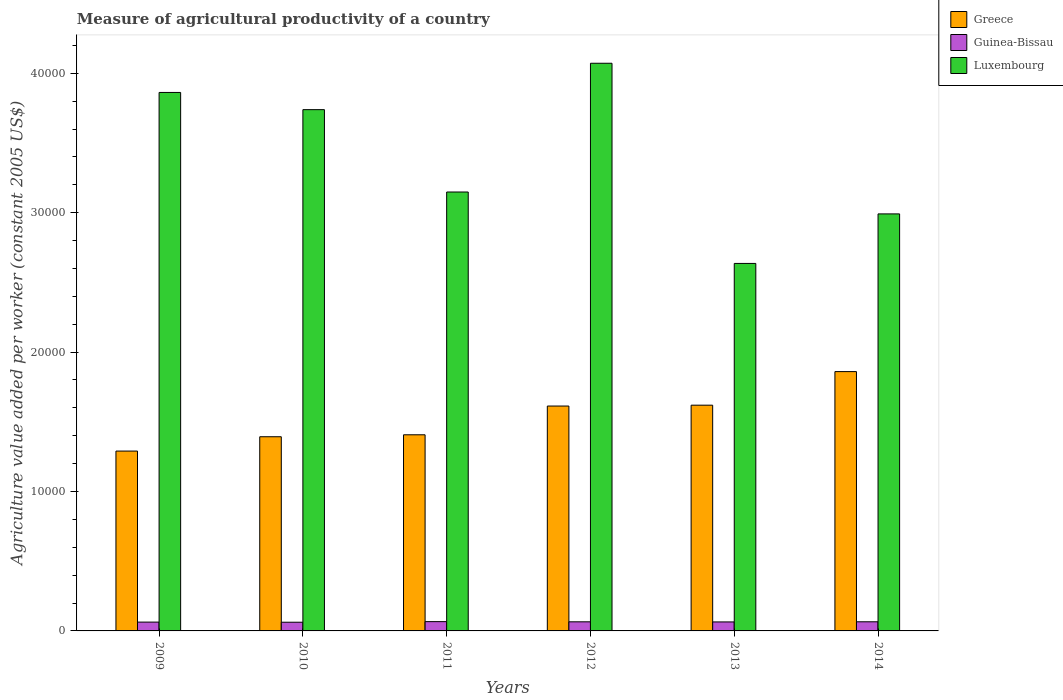How many groups of bars are there?
Give a very brief answer. 6. Are the number of bars per tick equal to the number of legend labels?
Provide a succinct answer. Yes. What is the label of the 3rd group of bars from the left?
Provide a succinct answer. 2011. In how many cases, is the number of bars for a given year not equal to the number of legend labels?
Ensure brevity in your answer.  0. What is the measure of agricultural productivity in Luxembourg in 2012?
Offer a very short reply. 4.07e+04. Across all years, what is the maximum measure of agricultural productivity in Greece?
Ensure brevity in your answer.  1.86e+04. Across all years, what is the minimum measure of agricultural productivity in Luxembourg?
Your answer should be very brief. 2.64e+04. What is the total measure of agricultural productivity in Guinea-Bissau in the graph?
Keep it short and to the point. 3874.02. What is the difference between the measure of agricultural productivity in Guinea-Bissau in 2009 and that in 2011?
Your response must be concise. -33.61. What is the difference between the measure of agricultural productivity in Guinea-Bissau in 2011 and the measure of agricultural productivity in Greece in 2010?
Give a very brief answer. -1.33e+04. What is the average measure of agricultural productivity in Greece per year?
Ensure brevity in your answer.  1.53e+04. In the year 2014, what is the difference between the measure of agricultural productivity in Luxembourg and measure of agricultural productivity in Greece?
Give a very brief answer. 1.13e+04. What is the ratio of the measure of agricultural productivity in Guinea-Bissau in 2009 to that in 2010?
Make the answer very short. 1.01. Is the measure of agricultural productivity in Luxembourg in 2013 less than that in 2014?
Your answer should be compact. Yes. What is the difference between the highest and the second highest measure of agricultural productivity in Guinea-Bissau?
Keep it short and to the point. 11.04. What is the difference between the highest and the lowest measure of agricultural productivity in Luxembourg?
Your answer should be very brief. 1.44e+04. What does the 2nd bar from the left in 2010 represents?
Keep it short and to the point. Guinea-Bissau. What does the 3rd bar from the right in 2013 represents?
Give a very brief answer. Greece. Is it the case that in every year, the sum of the measure of agricultural productivity in Guinea-Bissau and measure of agricultural productivity in Luxembourg is greater than the measure of agricultural productivity in Greece?
Your answer should be very brief. Yes. What is the difference between two consecutive major ticks on the Y-axis?
Offer a very short reply. 10000. Where does the legend appear in the graph?
Your response must be concise. Top right. What is the title of the graph?
Your answer should be compact. Measure of agricultural productivity of a country. What is the label or title of the X-axis?
Offer a very short reply. Years. What is the label or title of the Y-axis?
Ensure brevity in your answer.  Agriculture value added per worker (constant 2005 US$). What is the Agriculture value added per worker (constant 2005 US$) of Greece in 2009?
Offer a terse response. 1.29e+04. What is the Agriculture value added per worker (constant 2005 US$) in Guinea-Bissau in 2009?
Your answer should be compact. 632.17. What is the Agriculture value added per worker (constant 2005 US$) in Luxembourg in 2009?
Give a very brief answer. 3.86e+04. What is the Agriculture value added per worker (constant 2005 US$) of Greece in 2010?
Provide a succinct answer. 1.39e+04. What is the Agriculture value added per worker (constant 2005 US$) of Guinea-Bissau in 2010?
Your answer should be very brief. 623.4. What is the Agriculture value added per worker (constant 2005 US$) in Luxembourg in 2010?
Your answer should be very brief. 3.74e+04. What is the Agriculture value added per worker (constant 2005 US$) of Greece in 2011?
Keep it short and to the point. 1.41e+04. What is the Agriculture value added per worker (constant 2005 US$) of Guinea-Bissau in 2011?
Your answer should be very brief. 665.78. What is the Agriculture value added per worker (constant 2005 US$) of Luxembourg in 2011?
Ensure brevity in your answer.  3.15e+04. What is the Agriculture value added per worker (constant 2005 US$) of Greece in 2012?
Offer a terse response. 1.61e+04. What is the Agriculture value added per worker (constant 2005 US$) of Guinea-Bissau in 2012?
Make the answer very short. 653.35. What is the Agriculture value added per worker (constant 2005 US$) of Luxembourg in 2012?
Give a very brief answer. 4.07e+04. What is the Agriculture value added per worker (constant 2005 US$) in Greece in 2013?
Your response must be concise. 1.62e+04. What is the Agriculture value added per worker (constant 2005 US$) of Guinea-Bissau in 2013?
Your response must be concise. 644.58. What is the Agriculture value added per worker (constant 2005 US$) of Luxembourg in 2013?
Provide a short and direct response. 2.64e+04. What is the Agriculture value added per worker (constant 2005 US$) of Greece in 2014?
Your response must be concise. 1.86e+04. What is the Agriculture value added per worker (constant 2005 US$) of Guinea-Bissau in 2014?
Ensure brevity in your answer.  654.74. What is the Agriculture value added per worker (constant 2005 US$) of Luxembourg in 2014?
Ensure brevity in your answer.  2.99e+04. Across all years, what is the maximum Agriculture value added per worker (constant 2005 US$) in Greece?
Your answer should be very brief. 1.86e+04. Across all years, what is the maximum Agriculture value added per worker (constant 2005 US$) of Guinea-Bissau?
Your answer should be very brief. 665.78. Across all years, what is the maximum Agriculture value added per worker (constant 2005 US$) in Luxembourg?
Offer a very short reply. 4.07e+04. Across all years, what is the minimum Agriculture value added per worker (constant 2005 US$) in Greece?
Your answer should be compact. 1.29e+04. Across all years, what is the minimum Agriculture value added per worker (constant 2005 US$) in Guinea-Bissau?
Your answer should be very brief. 623.4. Across all years, what is the minimum Agriculture value added per worker (constant 2005 US$) in Luxembourg?
Make the answer very short. 2.64e+04. What is the total Agriculture value added per worker (constant 2005 US$) of Greece in the graph?
Provide a succinct answer. 9.18e+04. What is the total Agriculture value added per worker (constant 2005 US$) in Guinea-Bissau in the graph?
Make the answer very short. 3874.02. What is the total Agriculture value added per worker (constant 2005 US$) in Luxembourg in the graph?
Offer a terse response. 2.05e+05. What is the difference between the Agriculture value added per worker (constant 2005 US$) of Greece in 2009 and that in 2010?
Your answer should be compact. -1027.51. What is the difference between the Agriculture value added per worker (constant 2005 US$) in Guinea-Bissau in 2009 and that in 2010?
Provide a short and direct response. 8.76. What is the difference between the Agriculture value added per worker (constant 2005 US$) of Luxembourg in 2009 and that in 2010?
Your answer should be very brief. 1233.96. What is the difference between the Agriculture value added per worker (constant 2005 US$) of Greece in 2009 and that in 2011?
Your response must be concise. -1167.33. What is the difference between the Agriculture value added per worker (constant 2005 US$) in Guinea-Bissau in 2009 and that in 2011?
Your answer should be very brief. -33.61. What is the difference between the Agriculture value added per worker (constant 2005 US$) in Luxembourg in 2009 and that in 2011?
Your response must be concise. 7142.03. What is the difference between the Agriculture value added per worker (constant 2005 US$) of Greece in 2009 and that in 2012?
Ensure brevity in your answer.  -3229.62. What is the difference between the Agriculture value added per worker (constant 2005 US$) of Guinea-Bissau in 2009 and that in 2012?
Provide a short and direct response. -21.18. What is the difference between the Agriculture value added per worker (constant 2005 US$) in Luxembourg in 2009 and that in 2012?
Provide a succinct answer. -2094. What is the difference between the Agriculture value added per worker (constant 2005 US$) in Greece in 2009 and that in 2013?
Offer a terse response. -3290.91. What is the difference between the Agriculture value added per worker (constant 2005 US$) of Guinea-Bissau in 2009 and that in 2013?
Your response must be concise. -12.42. What is the difference between the Agriculture value added per worker (constant 2005 US$) in Luxembourg in 2009 and that in 2013?
Your response must be concise. 1.23e+04. What is the difference between the Agriculture value added per worker (constant 2005 US$) of Greece in 2009 and that in 2014?
Offer a very short reply. -5699.73. What is the difference between the Agriculture value added per worker (constant 2005 US$) in Guinea-Bissau in 2009 and that in 2014?
Provide a short and direct response. -22.57. What is the difference between the Agriculture value added per worker (constant 2005 US$) of Luxembourg in 2009 and that in 2014?
Your response must be concise. 8712.53. What is the difference between the Agriculture value added per worker (constant 2005 US$) of Greece in 2010 and that in 2011?
Your answer should be very brief. -139.82. What is the difference between the Agriculture value added per worker (constant 2005 US$) in Guinea-Bissau in 2010 and that in 2011?
Provide a succinct answer. -42.37. What is the difference between the Agriculture value added per worker (constant 2005 US$) in Luxembourg in 2010 and that in 2011?
Make the answer very short. 5908.07. What is the difference between the Agriculture value added per worker (constant 2005 US$) in Greece in 2010 and that in 2012?
Your response must be concise. -2202.1. What is the difference between the Agriculture value added per worker (constant 2005 US$) of Guinea-Bissau in 2010 and that in 2012?
Your answer should be very brief. -29.95. What is the difference between the Agriculture value added per worker (constant 2005 US$) of Luxembourg in 2010 and that in 2012?
Keep it short and to the point. -3327.96. What is the difference between the Agriculture value added per worker (constant 2005 US$) of Greece in 2010 and that in 2013?
Your response must be concise. -2263.4. What is the difference between the Agriculture value added per worker (constant 2005 US$) in Guinea-Bissau in 2010 and that in 2013?
Give a very brief answer. -21.18. What is the difference between the Agriculture value added per worker (constant 2005 US$) of Luxembourg in 2010 and that in 2013?
Offer a very short reply. 1.10e+04. What is the difference between the Agriculture value added per worker (constant 2005 US$) of Greece in 2010 and that in 2014?
Your answer should be compact. -4672.22. What is the difference between the Agriculture value added per worker (constant 2005 US$) of Guinea-Bissau in 2010 and that in 2014?
Provide a succinct answer. -31.33. What is the difference between the Agriculture value added per worker (constant 2005 US$) in Luxembourg in 2010 and that in 2014?
Make the answer very short. 7478.56. What is the difference between the Agriculture value added per worker (constant 2005 US$) of Greece in 2011 and that in 2012?
Offer a terse response. -2062.28. What is the difference between the Agriculture value added per worker (constant 2005 US$) in Guinea-Bissau in 2011 and that in 2012?
Provide a short and direct response. 12.43. What is the difference between the Agriculture value added per worker (constant 2005 US$) of Luxembourg in 2011 and that in 2012?
Give a very brief answer. -9236.03. What is the difference between the Agriculture value added per worker (constant 2005 US$) in Greece in 2011 and that in 2013?
Offer a terse response. -2123.57. What is the difference between the Agriculture value added per worker (constant 2005 US$) in Guinea-Bissau in 2011 and that in 2013?
Make the answer very short. 21.19. What is the difference between the Agriculture value added per worker (constant 2005 US$) in Luxembourg in 2011 and that in 2013?
Your response must be concise. 5122.82. What is the difference between the Agriculture value added per worker (constant 2005 US$) of Greece in 2011 and that in 2014?
Offer a terse response. -4532.4. What is the difference between the Agriculture value added per worker (constant 2005 US$) in Guinea-Bissau in 2011 and that in 2014?
Your response must be concise. 11.04. What is the difference between the Agriculture value added per worker (constant 2005 US$) in Luxembourg in 2011 and that in 2014?
Your answer should be very brief. 1570.5. What is the difference between the Agriculture value added per worker (constant 2005 US$) in Greece in 2012 and that in 2013?
Make the answer very short. -61.29. What is the difference between the Agriculture value added per worker (constant 2005 US$) of Guinea-Bissau in 2012 and that in 2013?
Provide a succinct answer. 8.77. What is the difference between the Agriculture value added per worker (constant 2005 US$) of Luxembourg in 2012 and that in 2013?
Keep it short and to the point. 1.44e+04. What is the difference between the Agriculture value added per worker (constant 2005 US$) in Greece in 2012 and that in 2014?
Provide a short and direct response. -2470.11. What is the difference between the Agriculture value added per worker (constant 2005 US$) of Guinea-Bissau in 2012 and that in 2014?
Offer a very short reply. -1.38. What is the difference between the Agriculture value added per worker (constant 2005 US$) of Luxembourg in 2012 and that in 2014?
Your answer should be very brief. 1.08e+04. What is the difference between the Agriculture value added per worker (constant 2005 US$) in Greece in 2013 and that in 2014?
Offer a terse response. -2408.82. What is the difference between the Agriculture value added per worker (constant 2005 US$) in Guinea-Bissau in 2013 and that in 2014?
Provide a short and direct response. -10.15. What is the difference between the Agriculture value added per worker (constant 2005 US$) in Luxembourg in 2013 and that in 2014?
Offer a terse response. -3552.32. What is the difference between the Agriculture value added per worker (constant 2005 US$) of Greece in 2009 and the Agriculture value added per worker (constant 2005 US$) of Guinea-Bissau in 2010?
Provide a succinct answer. 1.23e+04. What is the difference between the Agriculture value added per worker (constant 2005 US$) of Greece in 2009 and the Agriculture value added per worker (constant 2005 US$) of Luxembourg in 2010?
Offer a terse response. -2.45e+04. What is the difference between the Agriculture value added per worker (constant 2005 US$) of Guinea-Bissau in 2009 and the Agriculture value added per worker (constant 2005 US$) of Luxembourg in 2010?
Provide a succinct answer. -3.68e+04. What is the difference between the Agriculture value added per worker (constant 2005 US$) of Greece in 2009 and the Agriculture value added per worker (constant 2005 US$) of Guinea-Bissau in 2011?
Your answer should be very brief. 1.22e+04. What is the difference between the Agriculture value added per worker (constant 2005 US$) of Greece in 2009 and the Agriculture value added per worker (constant 2005 US$) of Luxembourg in 2011?
Your response must be concise. -1.86e+04. What is the difference between the Agriculture value added per worker (constant 2005 US$) in Guinea-Bissau in 2009 and the Agriculture value added per worker (constant 2005 US$) in Luxembourg in 2011?
Make the answer very short. -3.09e+04. What is the difference between the Agriculture value added per worker (constant 2005 US$) in Greece in 2009 and the Agriculture value added per worker (constant 2005 US$) in Guinea-Bissau in 2012?
Make the answer very short. 1.22e+04. What is the difference between the Agriculture value added per worker (constant 2005 US$) of Greece in 2009 and the Agriculture value added per worker (constant 2005 US$) of Luxembourg in 2012?
Your answer should be very brief. -2.78e+04. What is the difference between the Agriculture value added per worker (constant 2005 US$) of Guinea-Bissau in 2009 and the Agriculture value added per worker (constant 2005 US$) of Luxembourg in 2012?
Ensure brevity in your answer.  -4.01e+04. What is the difference between the Agriculture value added per worker (constant 2005 US$) of Greece in 2009 and the Agriculture value added per worker (constant 2005 US$) of Guinea-Bissau in 2013?
Give a very brief answer. 1.23e+04. What is the difference between the Agriculture value added per worker (constant 2005 US$) in Greece in 2009 and the Agriculture value added per worker (constant 2005 US$) in Luxembourg in 2013?
Ensure brevity in your answer.  -1.35e+04. What is the difference between the Agriculture value added per worker (constant 2005 US$) of Guinea-Bissau in 2009 and the Agriculture value added per worker (constant 2005 US$) of Luxembourg in 2013?
Give a very brief answer. -2.57e+04. What is the difference between the Agriculture value added per worker (constant 2005 US$) in Greece in 2009 and the Agriculture value added per worker (constant 2005 US$) in Guinea-Bissau in 2014?
Make the answer very short. 1.22e+04. What is the difference between the Agriculture value added per worker (constant 2005 US$) of Greece in 2009 and the Agriculture value added per worker (constant 2005 US$) of Luxembourg in 2014?
Ensure brevity in your answer.  -1.70e+04. What is the difference between the Agriculture value added per worker (constant 2005 US$) in Guinea-Bissau in 2009 and the Agriculture value added per worker (constant 2005 US$) in Luxembourg in 2014?
Your answer should be very brief. -2.93e+04. What is the difference between the Agriculture value added per worker (constant 2005 US$) of Greece in 2010 and the Agriculture value added per worker (constant 2005 US$) of Guinea-Bissau in 2011?
Provide a succinct answer. 1.33e+04. What is the difference between the Agriculture value added per worker (constant 2005 US$) of Greece in 2010 and the Agriculture value added per worker (constant 2005 US$) of Luxembourg in 2011?
Offer a terse response. -1.76e+04. What is the difference between the Agriculture value added per worker (constant 2005 US$) in Guinea-Bissau in 2010 and the Agriculture value added per worker (constant 2005 US$) in Luxembourg in 2011?
Your answer should be compact. -3.09e+04. What is the difference between the Agriculture value added per worker (constant 2005 US$) of Greece in 2010 and the Agriculture value added per worker (constant 2005 US$) of Guinea-Bissau in 2012?
Make the answer very short. 1.33e+04. What is the difference between the Agriculture value added per worker (constant 2005 US$) of Greece in 2010 and the Agriculture value added per worker (constant 2005 US$) of Luxembourg in 2012?
Your answer should be compact. -2.68e+04. What is the difference between the Agriculture value added per worker (constant 2005 US$) of Guinea-Bissau in 2010 and the Agriculture value added per worker (constant 2005 US$) of Luxembourg in 2012?
Keep it short and to the point. -4.01e+04. What is the difference between the Agriculture value added per worker (constant 2005 US$) in Greece in 2010 and the Agriculture value added per worker (constant 2005 US$) in Guinea-Bissau in 2013?
Your response must be concise. 1.33e+04. What is the difference between the Agriculture value added per worker (constant 2005 US$) in Greece in 2010 and the Agriculture value added per worker (constant 2005 US$) in Luxembourg in 2013?
Ensure brevity in your answer.  -1.24e+04. What is the difference between the Agriculture value added per worker (constant 2005 US$) of Guinea-Bissau in 2010 and the Agriculture value added per worker (constant 2005 US$) of Luxembourg in 2013?
Ensure brevity in your answer.  -2.57e+04. What is the difference between the Agriculture value added per worker (constant 2005 US$) in Greece in 2010 and the Agriculture value added per worker (constant 2005 US$) in Guinea-Bissau in 2014?
Offer a terse response. 1.33e+04. What is the difference between the Agriculture value added per worker (constant 2005 US$) of Greece in 2010 and the Agriculture value added per worker (constant 2005 US$) of Luxembourg in 2014?
Your answer should be very brief. -1.60e+04. What is the difference between the Agriculture value added per worker (constant 2005 US$) in Guinea-Bissau in 2010 and the Agriculture value added per worker (constant 2005 US$) in Luxembourg in 2014?
Your answer should be compact. -2.93e+04. What is the difference between the Agriculture value added per worker (constant 2005 US$) in Greece in 2011 and the Agriculture value added per worker (constant 2005 US$) in Guinea-Bissau in 2012?
Provide a short and direct response. 1.34e+04. What is the difference between the Agriculture value added per worker (constant 2005 US$) in Greece in 2011 and the Agriculture value added per worker (constant 2005 US$) in Luxembourg in 2012?
Provide a short and direct response. -2.67e+04. What is the difference between the Agriculture value added per worker (constant 2005 US$) of Guinea-Bissau in 2011 and the Agriculture value added per worker (constant 2005 US$) of Luxembourg in 2012?
Your response must be concise. -4.01e+04. What is the difference between the Agriculture value added per worker (constant 2005 US$) of Greece in 2011 and the Agriculture value added per worker (constant 2005 US$) of Guinea-Bissau in 2013?
Offer a very short reply. 1.34e+04. What is the difference between the Agriculture value added per worker (constant 2005 US$) of Greece in 2011 and the Agriculture value added per worker (constant 2005 US$) of Luxembourg in 2013?
Offer a terse response. -1.23e+04. What is the difference between the Agriculture value added per worker (constant 2005 US$) of Guinea-Bissau in 2011 and the Agriculture value added per worker (constant 2005 US$) of Luxembourg in 2013?
Ensure brevity in your answer.  -2.57e+04. What is the difference between the Agriculture value added per worker (constant 2005 US$) in Greece in 2011 and the Agriculture value added per worker (constant 2005 US$) in Guinea-Bissau in 2014?
Keep it short and to the point. 1.34e+04. What is the difference between the Agriculture value added per worker (constant 2005 US$) in Greece in 2011 and the Agriculture value added per worker (constant 2005 US$) in Luxembourg in 2014?
Keep it short and to the point. -1.58e+04. What is the difference between the Agriculture value added per worker (constant 2005 US$) in Guinea-Bissau in 2011 and the Agriculture value added per worker (constant 2005 US$) in Luxembourg in 2014?
Your answer should be compact. -2.92e+04. What is the difference between the Agriculture value added per worker (constant 2005 US$) in Greece in 2012 and the Agriculture value added per worker (constant 2005 US$) in Guinea-Bissau in 2013?
Make the answer very short. 1.55e+04. What is the difference between the Agriculture value added per worker (constant 2005 US$) in Greece in 2012 and the Agriculture value added per worker (constant 2005 US$) in Luxembourg in 2013?
Make the answer very short. -1.02e+04. What is the difference between the Agriculture value added per worker (constant 2005 US$) in Guinea-Bissau in 2012 and the Agriculture value added per worker (constant 2005 US$) in Luxembourg in 2013?
Ensure brevity in your answer.  -2.57e+04. What is the difference between the Agriculture value added per worker (constant 2005 US$) in Greece in 2012 and the Agriculture value added per worker (constant 2005 US$) in Guinea-Bissau in 2014?
Your response must be concise. 1.55e+04. What is the difference between the Agriculture value added per worker (constant 2005 US$) in Greece in 2012 and the Agriculture value added per worker (constant 2005 US$) in Luxembourg in 2014?
Make the answer very short. -1.38e+04. What is the difference between the Agriculture value added per worker (constant 2005 US$) of Guinea-Bissau in 2012 and the Agriculture value added per worker (constant 2005 US$) of Luxembourg in 2014?
Ensure brevity in your answer.  -2.93e+04. What is the difference between the Agriculture value added per worker (constant 2005 US$) of Greece in 2013 and the Agriculture value added per worker (constant 2005 US$) of Guinea-Bissau in 2014?
Your answer should be compact. 1.55e+04. What is the difference between the Agriculture value added per worker (constant 2005 US$) in Greece in 2013 and the Agriculture value added per worker (constant 2005 US$) in Luxembourg in 2014?
Your answer should be very brief. -1.37e+04. What is the difference between the Agriculture value added per worker (constant 2005 US$) in Guinea-Bissau in 2013 and the Agriculture value added per worker (constant 2005 US$) in Luxembourg in 2014?
Ensure brevity in your answer.  -2.93e+04. What is the average Agriculture value added per worker (constant 2005 US$) in Greece per year?
Make the answer very short. 1.53e+04. What is the average Agriculture value added per worker (constant 2005 US$) of Guinea-Bissau per year?
Your response must be concise. 645.67. What is the average Agriculture value added per worker (constant 2005 US$) in Luxembourg per year?
Your answer should be compact. 3.41e+04. In the year 2009, what is the difference between the Agriculture value added per worker (constant 2005 US$) of Greece and Agriculture value added per worker (constant 2005 US$) of Guinea-Bissau?
Offer a terse response. 1.23e+04. In the year 2009, what is the difference between the Agriculture value added per worker (constant 2005 US$) of Greece and Agriculture value added per worker (constant 2005 US$) of Luxembourg?
Provide a succinct answer. -2.57e+04. In the year 2009, what is the difference between the Agriculture value added per worker (constant 2005 US$) in Guinea-Bissau and Agriculture value added per worker (constant 2005 US$) in Luxembourg?
Provide a short and direct response. -3.80e+04. In the year 2010, what is the difference between the Agriculture value added per worker (constant 2005 US$) in Greece and Agriculture value added per worker (constant 2005 US$) in Guinea-Bissau?
Your answer should be compact. 1.33e+04. In the year 2010, what is the difference between the Agriculture value added per worker (constant 2005 US$) of Greece and Agriculture value added per worker (constant 2005 US$) of Luxembourg?
Your answer should be compact. -2.35e+04. In the year 2010, what is the difference between the Agriculture value added per worker (constant 2005 US$) in Guinea-Bissau and Agriculture value added per worker (constant 2005 US$) in Luxembourg?
Make the answer very short. -3.68e+04. In the year 2011, what is the difference between the Agriculture value added per worker (constant 2005 US$) of Greece and Agriculture value added per worker (constant 2005 US$) of Guinea-Bissau?
Offer a terse response. 1.34e+04. In the year 2011, what is the difference between the Agriculture value added per worker (constant 2005 US$) of Greece and Agriculture value added per worker (constant 2005 US$) of Luxembourg?
Your response must be concise. -1.74e+04. In the year 2011, what is the difference between the Agriculture value added per worker (constant 2005 US$) in Guinea-Bissau and Agriculture value added per worker (constant 2005 US$) in Luxembourg?
Your response must be concise. -3.08e+04. In the year 2012, what is the difference between the Agriculture value added per worker (constant 2005 US$) in Greece and Agriculture value added per worker (constant 2005 US$) in Guinea-Bissau?
Provide a succinct answer. 1.55e+04. In the year 2012, what is the difference between the Agriculture value added per worker (constant 2005 US$) of Greece and Agriculture value added per worker (constant 2005 US$) of Luxembourg?
Make the answer very short. -2.46e+04. In the year 2012, what is the difference between the Agriculture value added per worker (constant 2005 US$) in Guinea-Bissau and Agriculture value added per worker (constant 2005 US$) in Luxembourg?
Provide a short and direct response. -4.01e+04. In the year 2013, what is the difference between the Agriculture value added per worker (constant 2005 US$) of Greece and Agriculture value added per worker (constant 2005 US$) of Guinea-Bissau?
Offer a very short reply. 1.55e+04. In the year 2013, what is the difference between the Agriculture value added per worker (constant 2005 US$) of Greece and Agriculture value added per worker (constant 2005 US$) of Luxembourg?
Provide a succinct answer. -1.02e+04. In the year 2013, what is the difference between the Agriculture value added per worker (constant 2005 US$) in Guinea-Bissau and Agriculture value added per worker (constant 2005 US$) in Luxembourg?
Give a very brief answer. -2.57e+04. In the year 2014, what is the difference between the Agriculture value added per worker (constant 2005 US$) in Greece and Agriculture value added per worker (constant 2005 US$) in Guinea-Bissau?
Offer a very short reply. 1.79e+04. In the year 2014, what is the difference between the Agriculture value added per worker (constant 2005 US$) in Greece and Agriculture value added per worker (constant 2005 US$) in Luxembourg?
Provide a short and direct response. -1.13e+04. In the year 2014, what is the difference between the Agriculture value added per worker (constant 2005 US$) in Guinea-Bissau and Agriculture value added per worker (constant 2005 US$) in Luxembourg?
Offer a terse response. -2.93e+04. What is the ratio of the Agriculture value added per worker (constant 2005 US$) in Greece in 2009 to that in 2010?
Make the answer very short. 0.93. What is the ratio of the Agriculture value added per worker (constant 2005 US$) in Guinea-Bissau in 2009 to that in 2010?
Provide a short and direct response. 1.01. What is the ratio of the Agriculture value added per worker (constant 2005 US$) of Luxembourg in 2009 to that in 2010?
Ensure brevity in your answer.  1.03. What is the ratio of the Agriculture value added per worker (constant 2005 US$) of Greece in 2009 to that in 2011?
Offer a very short reply. 0.92. What is the ratio of the Agriculture value added per worker (constant 2005 US$) in Guinea-Bissau in 2009 to that in 2011?
Your answer should be compact. 0.95. What is the ratio of the Agriculture value added per worker (constant 2005 US$) of Luxembourg in 2009 to that in 2011?
Make the answer very short. 1.23. What is the ratio of the Agriculture value added per worker (constant 2005 US$) of Greece in 2009 to that in 2012?
Provide a succinct answer. 0.8. What is the ratio of the Agriculture value added per worker (constant 2005 US$) of Guinea-Bissau in 2009 to that in 2012?
Offer a very short reply. 0.97. What is the ratio of the Agriculture value added per worker (constant 2005 US$) in Luxembourg in 2009 to that in 2012?
Provide a succinct answer. 0.95. What is the ratio of the Agriculture value added per worker (constant 2005 US$) of Greece in 2009 to that in 2013?
Offer a very short reply. 0.8. What is the ratio of the Agriculture value added per worker (constant 2005 US$) in Guinea-Bissau in 2009 to that in 2013?
Ensure brevity in your answer.  0.98. What is the ratio of the Agriculture value added per worker (constant 2005 US$) in Luxembourg in 2009 to that in 2013?
Ensure brevity in your answer.  1.47. What is the ratio of the Agriculture value added per worker (constant 2005 US$) of Greece in 2009 to that in 2014?
Provide a succinct answer. 0.69. What is the ratio of the Agriculture value added per worker (constant 2005 US$) of Guinea-Bissau in 2009 to that in 2014?
Provide a succinct answer. 0.97. What is the ratio of the Agriculture value added per worker (constant 2005 US$) of Luxembourg in 2009 to that in 2014?
Make the answer very short. 1.29. What is the ratio of the Agriculture value added per worker (constant 2005 US$) of Greece in 2010 to that in 2011?
Provide a succinct answer. 0.99. What is the ratio of the Agriculture value added per worker (constant 2005 US$) of Guinea-Bissau in 2010 to that in 2011?
Keep it short and to the point. 0.94. What is the ratio of the Agriculture value added per worker (constant 2005 US$) of Luxembourg in 2010 to that in 2011?
Ensure brevity in your answer.  1.19. What is the ratio of the Agriculture value added per worker (constant 2005 US$) of Greece in 2010 to that in 2012?
Your answer should be compact. 0.86. What is the ratio of the Agriculture value added per worker (constant 2005 US$) in Guinea-Bissau in 2010 to that in 2012?
Keep it short and to the point. 0.95. What is the ratio of the Agriculture value added per worker (constant 2005 US$) of Luxembourg in 2010 to that in 2012?
Your answer should be very brief. 0.92. What is the ratio of the Agriculture value added per worker (constant 2005 US$) of Greece in 2010 to that in 2013?
Provide a short and direct response. 0.86. What is the ratio of the Agriculture value added per worker (constant 2005 US$) of Guinea-Bissau in 2010 to that in 2013?
Offer a very short reply. 0.97. What is the ratio of the Agriculture value added per worker (constant 2005 US$) in Luxembourg in 2010 to that in 2013?
Offer a very short reply. 1.42. What is the ratio of the Agriculture value added per worker (constant 2005 US$) in Greece in 2010 to that in 2014?
Give a very brief answer. 0.75. What is the ratio of the Agriculture value added per worker (constant 2005 US$) in Guinea-Bissau in 2010 to that in 2014?
Make the answer very short. 0.95. What is the ratio of the Agriculture value added per worker (constant 2005 US$) of Greece in 2011 to that in 2012?
Your answer should be compact. 0.87. What is the ratio of the Agriculture value added per worker (constant 2005 US$) of Guinea-Bissau in 2011 to that in 2012?
Give a very brief answer. 1.02. What is the ratio of the Agriculture value added per worker (constant 2005 US$) in Luxembourg in 2011 to that in 2012?
Offer a very short reply. 0.77. What is the ratio of the Agriculture value added per worker (constant 2005 US$) of Greece in 2011 to that in 2013?
Keep it short and to the point. 0.87. What is the ratio of the Agriculture value added per worker (constant 2005 US$) in Guinea-Bissau in 2011 to that in 2013?
Give a very brief answer. 1.03. What is the ratio of the Agriculture value added per worker (constant 2005 US$) of Luxembourg in 2011 to that in 2013?
Offer a very short reply. 1.19. What is the ratio of the Agriculture value added per worker (constant 2005 US$) of Greece in 2011 to that in 2014?
Ensure brevity in your answer.  0.76. What is the ratio of the Agriculture value added per worker (constant 2005 US$) of Guinea-Bissau in 2011 to that in 2014?
Give a very brief answer. 1.02. What is the ratio of the Agriculture value added per worker (constant 2005 US$) of Luxembourg in 2011 to that in 2014?
Provide a succinct answer. 1.05. What is the ratio of the Agriculture value added per worker (constant 2005 US$) in Greece in 2012 to that in 2013?
Offer a very short reply. 1. What is the ratio of the Agriculture value added per worker (constant 2005 US$) of Guinea-Bissau in 2012 to that in 2013?
Your answer should be very brief. 1.01. What is the ratio of the Agriculture value added per worker (constant 2005 US$) of Luxembourg in 2012 to that in 2013?
Your answer should be compact. 1.54. What is the ratio of the Agriculture value added per worker (constant 2005 US$) in Greece in 2012 to that in 2014?
Provide a short and direct response. 0.87. What is the ratio of the Agriculture value added per worker (constant 2005 US$) of Guinea-Bissau in 2012 to that in 2014?
Your answer should be compact. 1. What is the ratio of the Agriculture value added per worker (constant 2005 US$) in Luxembourg in 2012 to that in 2014?
Your answer should be very brief. 1.36. What is the ratio of the Agriculture value added per worker (constant 2005 US$) of Greece in 2013 to that in 2014?
Your answer should be compact. 0.87. What is the ratio of the Agriculture value added per worker (constant 2005 US$) of Guinea-Bissau in 2013 to that in 2014?
Your response must be concise. 0.98. What is the ratio of the Agriculture value added per worker (constant 2005 US$) in Luxembourg in 2013 to that in 2014?
Provide a short and direct response. 0.88. What is the difference between the highest and the second highest Agriculture value added per worker (constant 2005 US$) in Greece?
Keep it short and to the point. 2408.82. What is the difference between the highest and the second highest Agriculture value added per worker (constant 2005 US$) in Guinea-Bissau?
Offer a very short reply. 11.04. What is the difference between the highest and the second highest Agriculture value added per worker (constant 2005 US$) in Luxembourg?
Provide a short and direct response. 2094. What is the difference between the highest and the lowest Agriculture value added per worker (constant 2005 US$) in Greece?
Offer a very short reply. 5699.73. What is the difference between the highest and the lowest Agriculture value added per worker (constant 2005 US$) in Guinea-Bissau?
Your answer should be compact. 42.37. What is the difference between the highest and the lowest Agriculture value added per worker (constant 2005 US$) in Luxembourg?
Provide a succinct answer. 1.44e+04. 